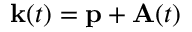Convert formula to latex. <formula><loc_0><loc_0><loc_500><loc_500>k ( t ) = p + A ( t )</formula> 